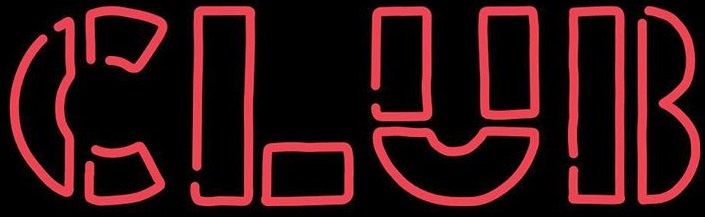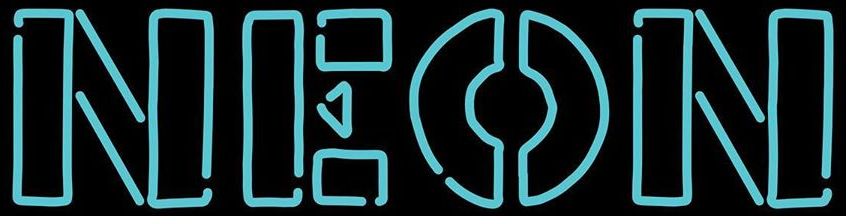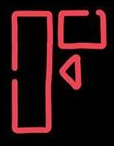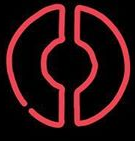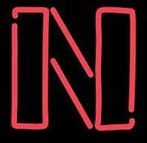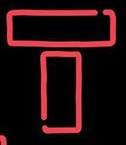What words are shown in these images in order, separated by a semicolon? CLUB; NEON; F; O; N; T 